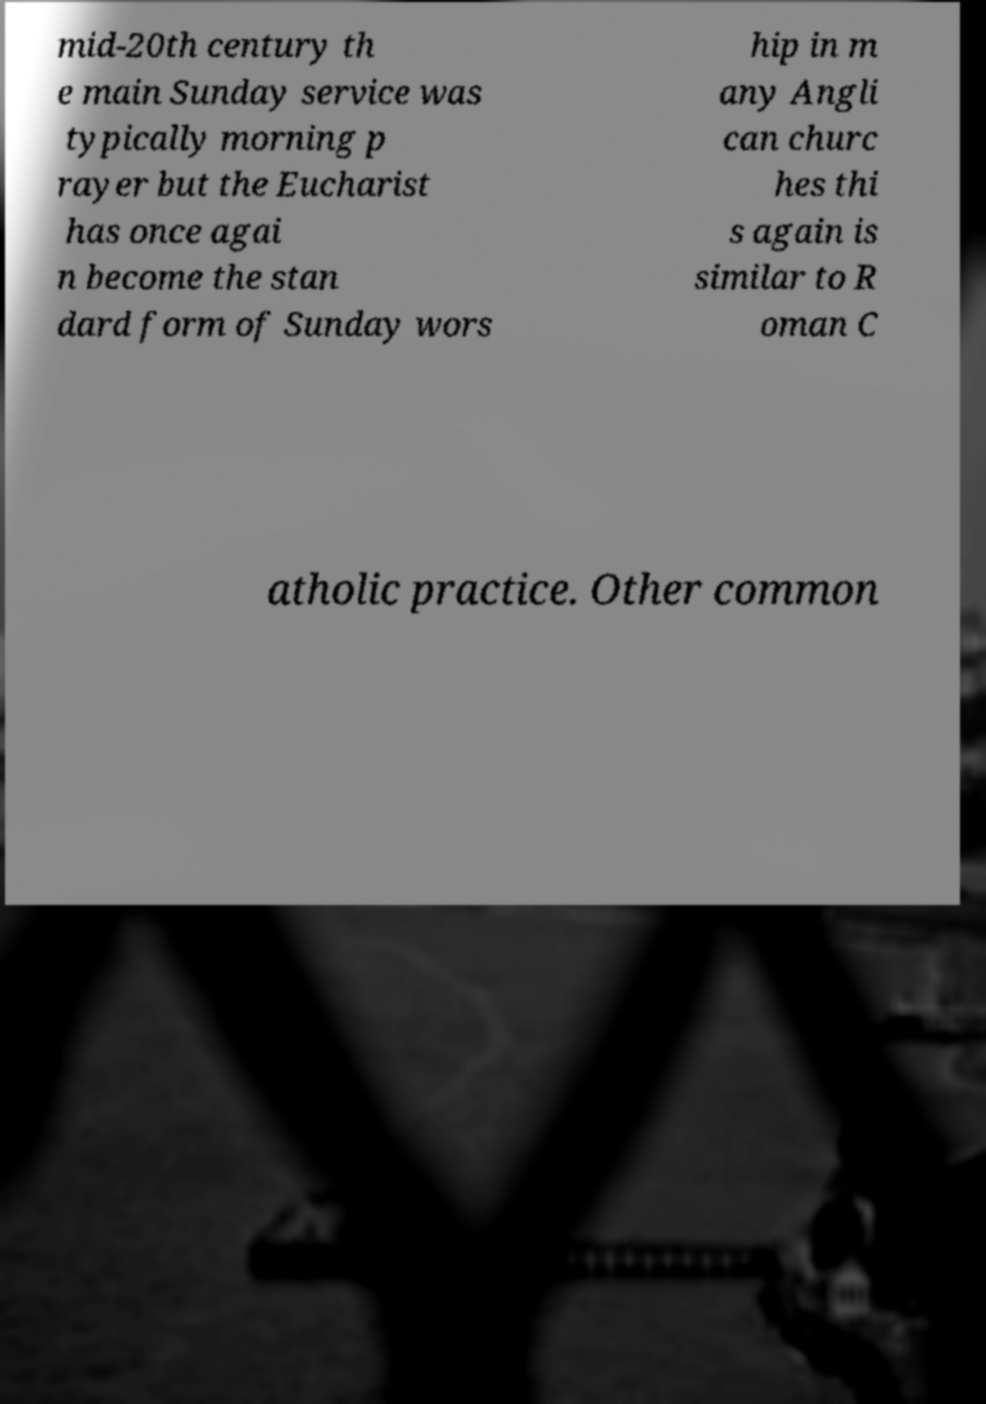What messages or text are displayed in this image? I need them in a readable, typed format. mid-20th century th e main Sunday service was typically morning p rayer but the Eucharist has once agai n become the stan dard form of Sunday wors hip in m any Angli can churc hes thi s again is similar to R oman C atholic practice. Other common 